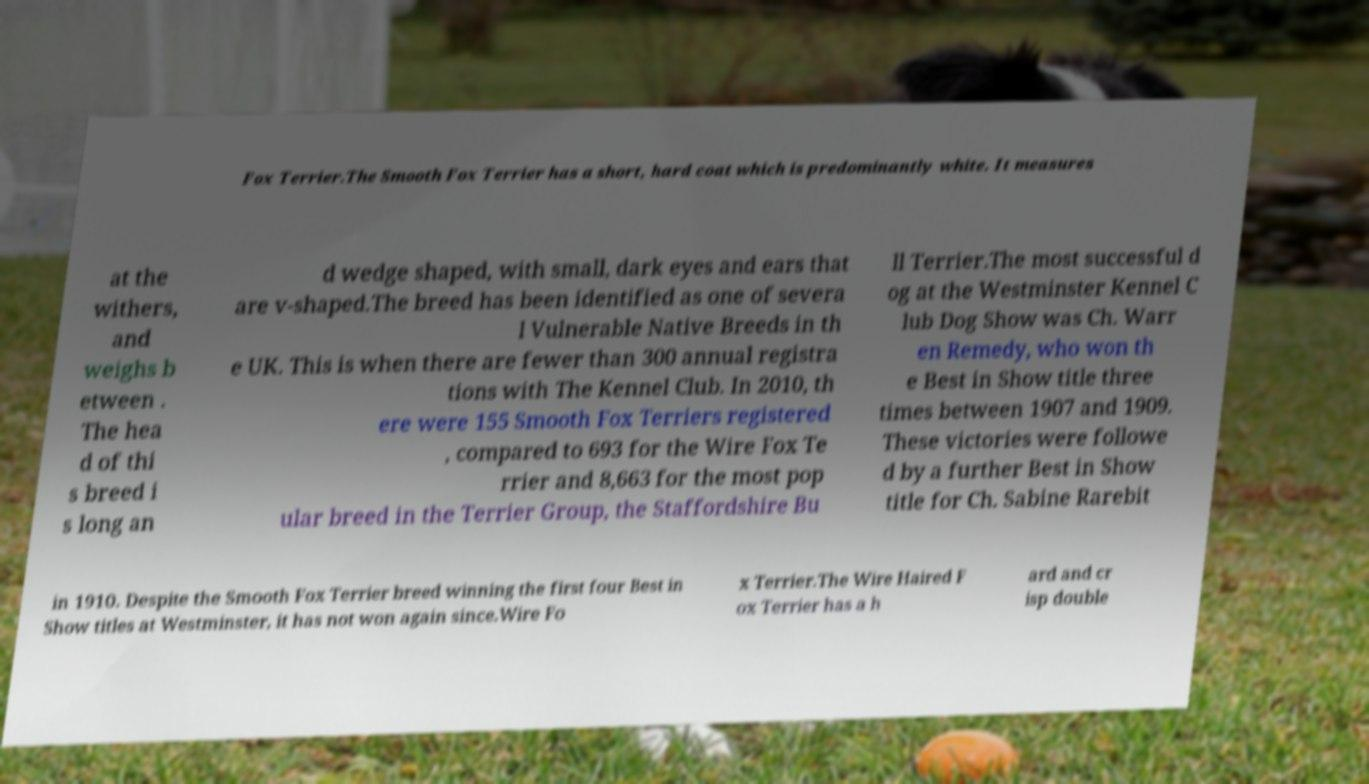Can you accurately transcribe the text from the provided image for me? Fox Terrier.The Smooth Fox Terrier has a short, hard coat which is predominantly white. It measures at the withers, and weighs b etween . The hea d of thi s breed i s long an d wedge shaped, with small, dark eyes and ears that are v-shaped.The breed has been identified as one of severa l Vulnerable Native Breeds in th e UK. This is when there are fewer than 300 annual registra tions with The Kennel Club. In 2010, th ere were 155 Smooth Fox Terriers registered , compared to 693 for the Wire Fox Te rrier and 8,663 for the most pop ular breed in the Terrier Group, the Staffordshire Bu ll Terrier.The most successful d og at the Westminster Kennel C lub Dog Show was Ch. Warr en Remedy, who won th e Best in Show title three times between 1907 and 1909. These victories were followe d by a further Best in Show title for Ch. Sabine Rarebit in 1910. Despite the Smooth Fox Terrier breed winning the first four Best in Show titles at Westminster, it has not won again since.Wire Fo x Terrier.The Wire Haired F ox Terrier has a h ard and cr isp double 